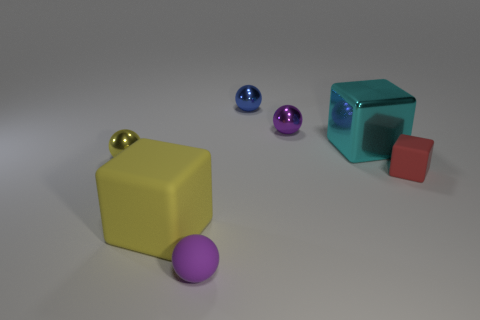How does the lighting in the scene affect the appearance of the objects? The lighting creates subtle highlights and soft shadows on the objects, which emphasizes their glossy textures and can give an impression of the three-dimensionality of the scene. 